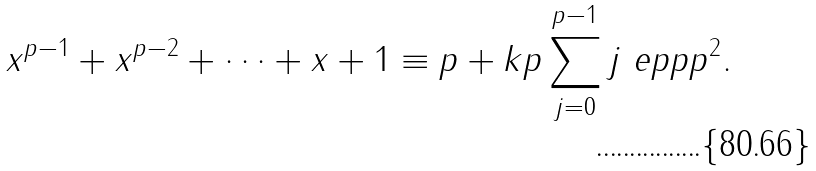<formula> <loc_0><loc_0><loc_500><loc_500>x ^ { p - 1 } + x ^ { p - 2 } + \dots + x + 1 \equiv p + k p \sum _ { j = 0 } ^ { p - 1 } j \ e p { p } { p ^ { 2 } } .</formula> 